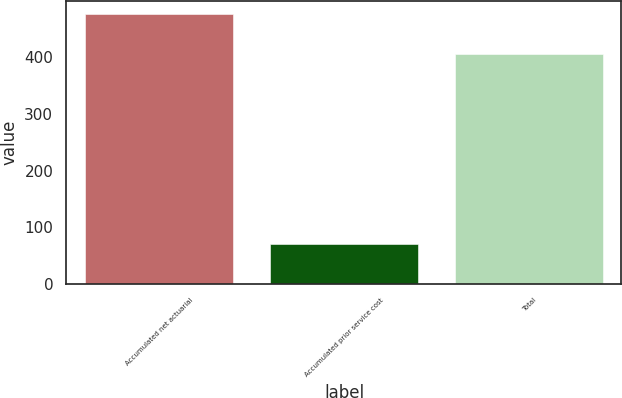<chart> <loc_0><loc_0><loc_500><loc_500><bar_chart><fcel>Accumulated net actuarial<fcel>Accumulated prior service cost<fcel>Total<nl><fcel>476<fcel>71<fcel>405<nl></chart> 